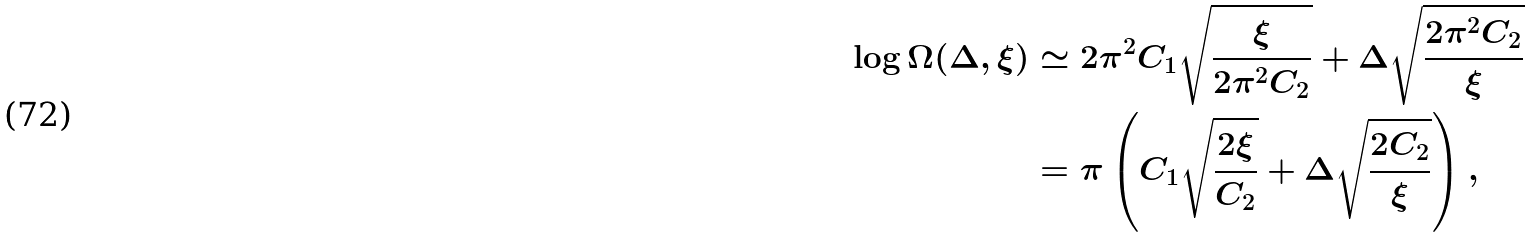<formula> <loc_0><loc_0><loc_500><loc_500>\log \Omega ( \Delta , \xi ) & \simeq 2 \pi ^ { 2 } C _ { 1 } \sqrt { \frac { \xi } { 2 \pi ^ { 2 } C _ { 2 } } } + \Delta \sqrt { \frac { 2 \pi ^ { 2 } C _ { 2 } } { \xi } } \\ & = \pi \left ( C _ { 1 } \sqrt { \frac { 2 \xi } { C _ { 2 } } } + \Delta \sqrt { \frac { 2 C _ { 2 } } { \xi } } \right ) ,</formula> 